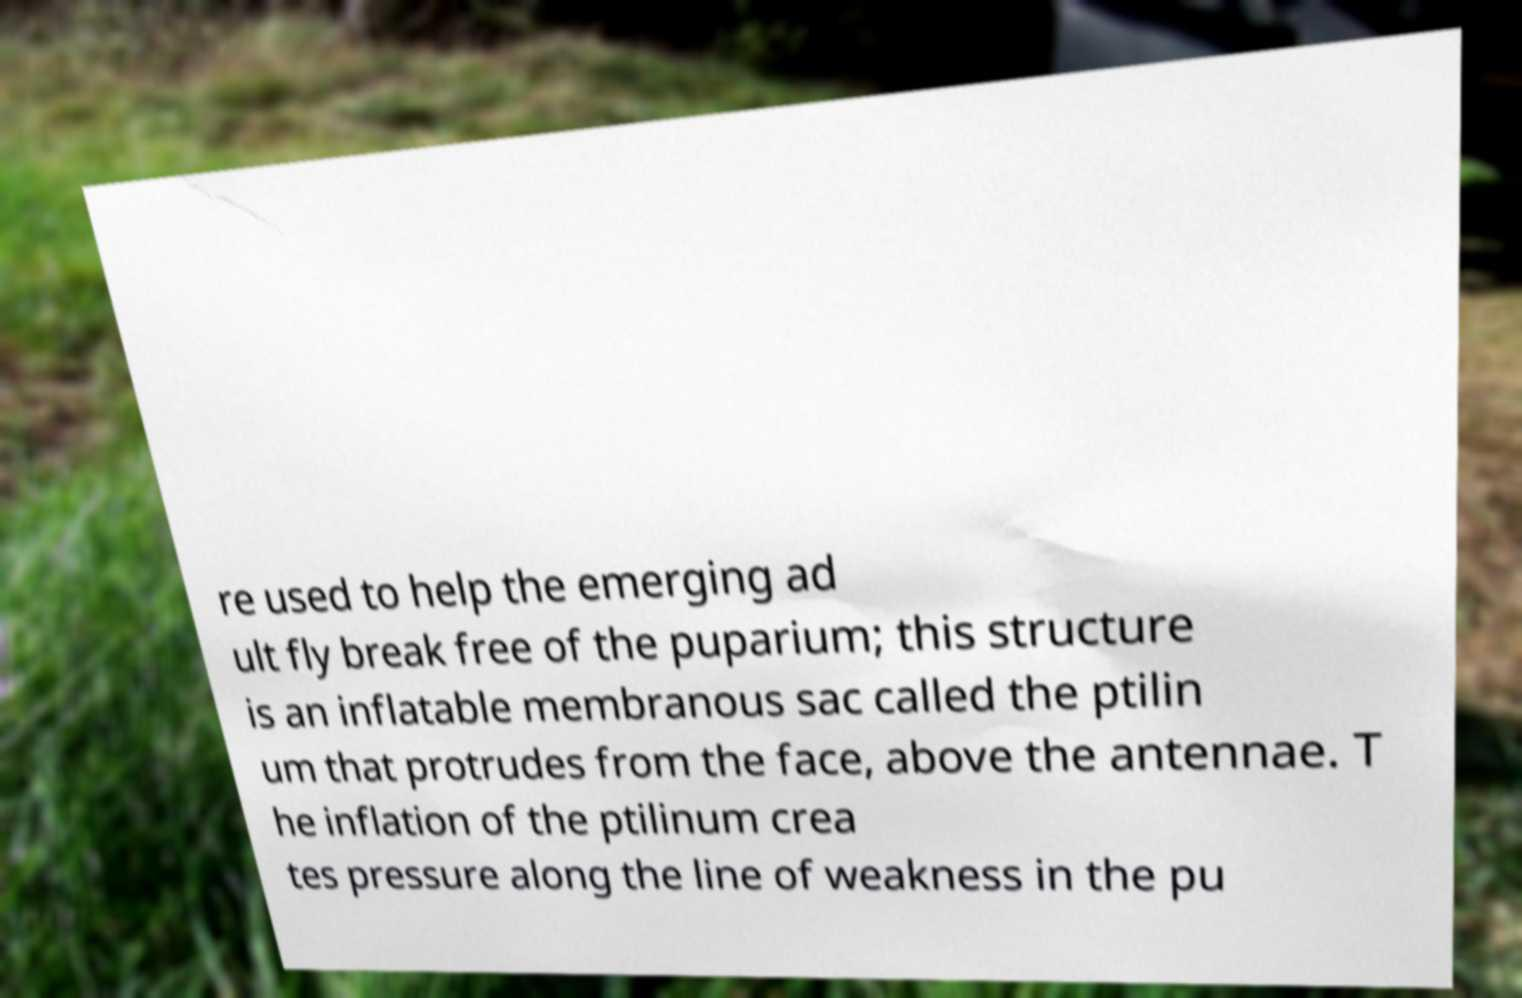Please identify and transcribe the text found in this image. re used to help the emerging ad ult fly break free of the puparium; this structure is an inflatable membranous sac called the ptilin um that protrudes from the face, above the antennae. T he inflation of the ptilinum crea tes pressure along the line of weakness in the pu 